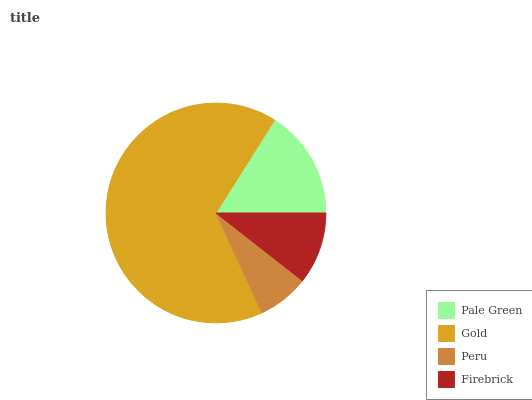Is Peru the minimum?
Answer yes or no. Yes. Is Gold the maximum?
Answer yes or no. Yes. Is Gold the minimum?
Answer yes or no. No. Is Peru the maximum?
Answer yes or no. No. Is Gold greater than Peru?
Answer yes or no. Yes. Is Peru less than Gold?
Answer yes or no. Yes. Is Peru greater than Gold?
Answer yes or no. No. Is Gold less than Peru?
Answer yes or no. No. Is Pale Green the high median?
Answer yes or no. Yes. Is Firebrick the low median?
Answer yes or no. Yes. Is Firebrick the high median?
Answer yes or no. No. Is Gold the low median?
Answer yes or no. No. 